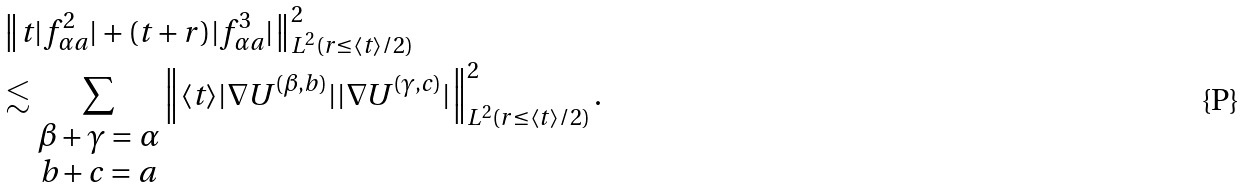<formula> <loc_0><loc_0><loc_500><loc_500>& \left \| t | f ^ { 2 } _ { \alpha a } | + ( t + r ) | f ^ { 3 } _ { \alpha a } | \right \| ^ { 2 } _ { L ^ { 2 } ( r \leq \langle t \rangle / 2 ) } \\ & \lesssim \sum _ { \begin{matrix} \beta + \gamma = \alpha \\ b + c = a \end{matrix} } \left \| \langle t \rangle | \nabla U ^ { ( \beta , b ) } | | \nabla U ^ { ( \gamma , c ) } | \right \| ^ { 2 } _ { L ^ { 2 } ( r \leq \langle t \rangle / 2 ) } .</formula> 